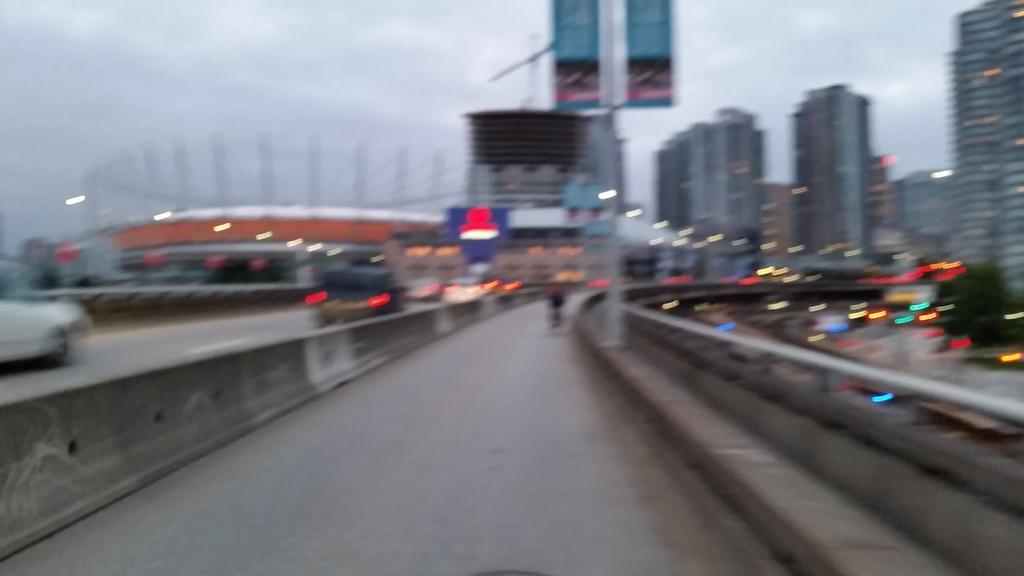What structure can be seen in the image? There is a bridge in the image. What else is visible around the bridge? There are many buildings around the bridge in the image. Can you describe the presence of vehicles in the image? There are vehicles moving on the bridge in the image, but this observation may be less reliable due to the blurry nature of the image. What type of beef is being cooked on the bridge in the image? There is no beef or any cooking activity present in the image; it features a bridge and surrounding buildings. Can you see a wren perched on the bridge in the image? There is no wren or any bird visible in the image; it only shows a bridge and buildings. 